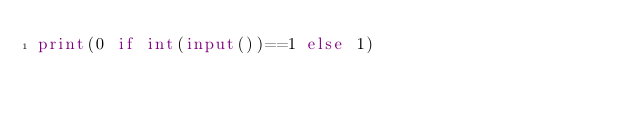Convert code to text. <code><loc_0><loc_0><loc_500><loc_500><_Python_>print(0 if int(input())==1 else 1)</code> 